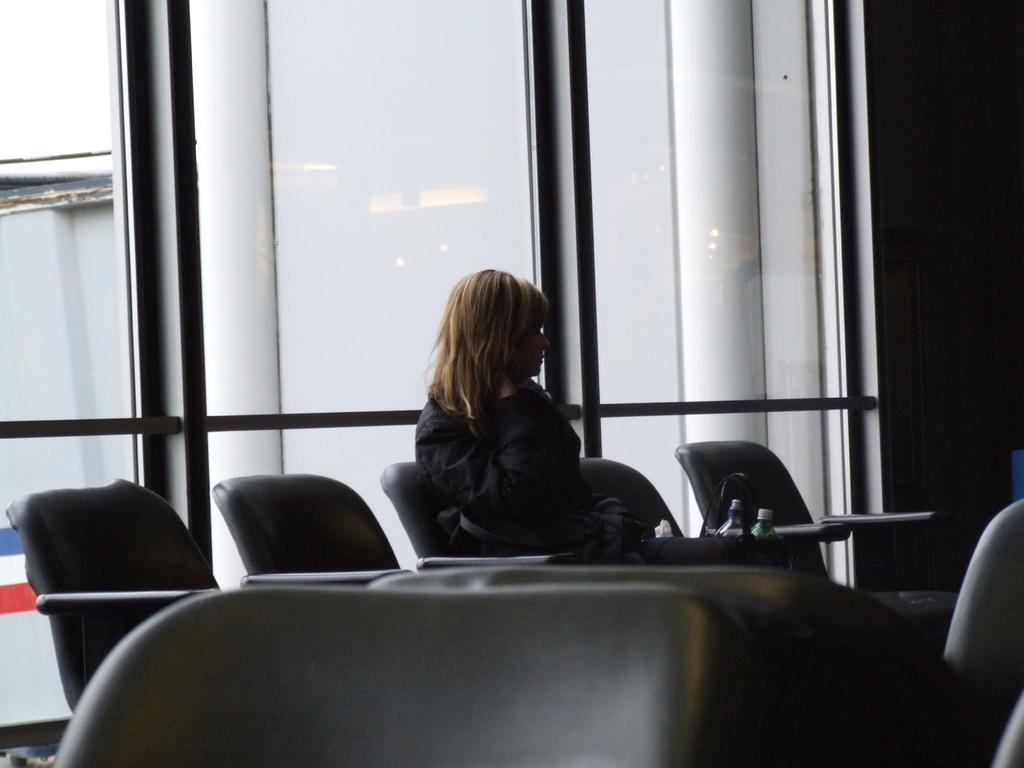What is the woman in the image doing? The woman is sitting on a chair in the image. What object is beside the woman? There is a handbag beside the woman. What is on the handbag? There are objects on the handbag. What can be seen in the image that is typically used for drinking? There is a glass visible in the image. What architectural feature can be seen in the background of the image? There is a pillar in the background of the image. How many ducks are swimming in the glass in the image? There are no ducks present in the image, and the glass is not depicted as containing water for ducks to swim in. 